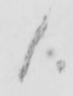Transcribe the text shown in this historical manuscript line. 1 . 